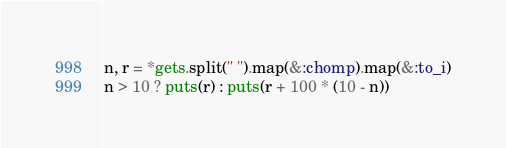Convert code to text. <code><loc_0><loc_0><loc_500><loc_500><_Ruby_>n, r = *gets.split(" ").map(&:chomp).map(&:to_i)
n > 10 ? puts(r) : puts(r + 100 * (10 - n))</code> 